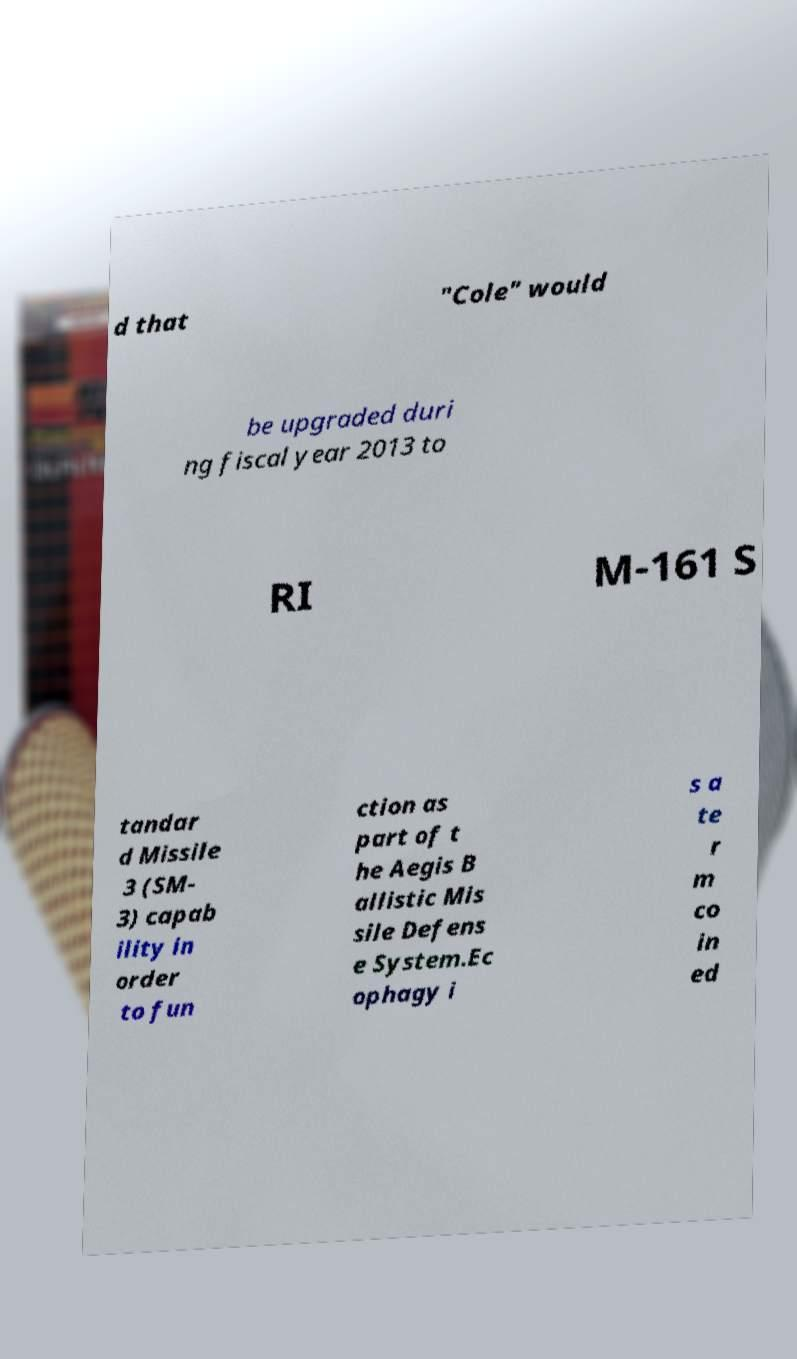Can you accurately transcribe the text from the provided image for me? d that "Cole" would be upgraded duri ng fiscal year 2013 to RI M-161 S tandar d Missile 3 (SM- 3) capab ility in order to fun ction as part of t he Aegis B allistic Mis sile Defens e System.Ec ophagy i s a te r m co in ed 